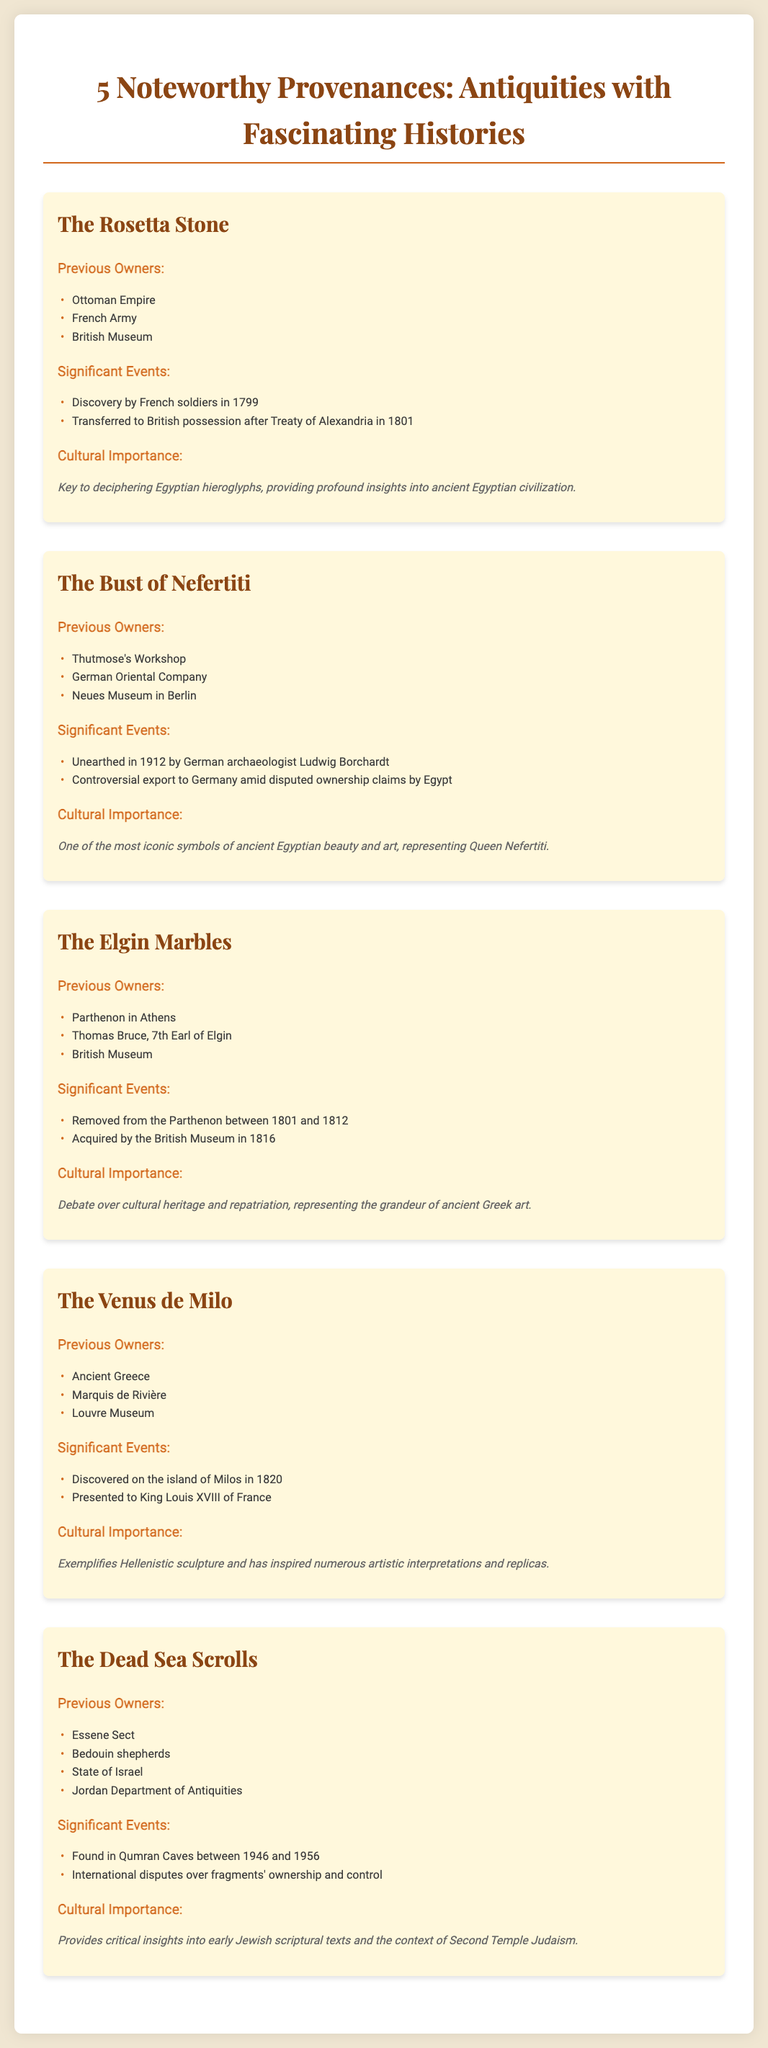What is the first significant event listed for The Rosetta Stone? The first significant event for The Rosetta Stone is its discovery by French soldiers in 1799.
Answer: Discovery by French soldiers in 1799 Who unearthed The Bust of Nefertiti? The Bust of Nefertiti was unearthed by German archaeologist Ludwig Borchardt in 1912.
Answer: Ludwig Borchardt How many previous owners are listed for The Elgin Marbles? The Elgin Marbles have three previous owners listed: the Parthenon in Athens, Thomas Bruce, and the British Museum.
Answer: Three What cultural significance is attributed to The Venus de Milo? The Venus de Milo exemplifies Hellenistic sculpture and has inspired numerous artistic interpretations and replicas.
Answer: Exemplifies Hellenistic sculpture Which two entities are mentioned in the context of ownership disputes over The Dead Sea Scrolls? The two entities mentioned are the State of Israel and the Jordan Department of Antiquities.
Answer: State of Israel and Jordan Department of Antiquities 